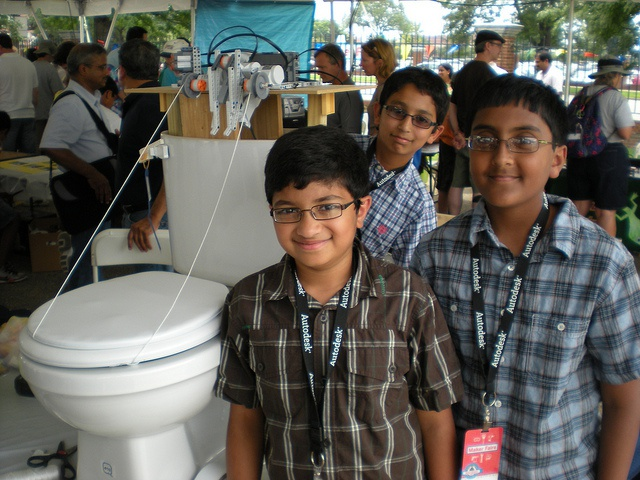Describe the objects in this image and their specific colors. I can see people in gray, black, darkgray, and maroon tones, people in gray, black, and maroon tones, toilet in gray, darkgray, and lightgray tones, people in gray, black, maroon, and darkgray tones, and people in gray, black, maroon, and darkblue tones in this image. 